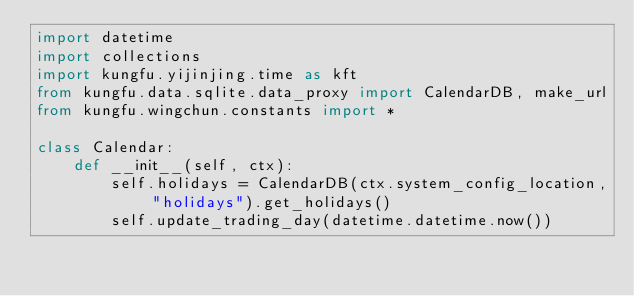<code> <loc_0><loc_0><loc_500><loc_500><_Python_>import datetime
import collections
import kungfu.yijinjing.time as kft
from kungfu.data.sqlite.data_proxy import CalendarDB, make_url
from kungfu.wingchun.constants import *

class Calendar:
    def __init__(self, ctx):
        self.holidays = CalendarDB(ctx.system_config_location, "holidays").get_holidays()
        self.update_trading_day(datetime.datetime.now())
</code> 